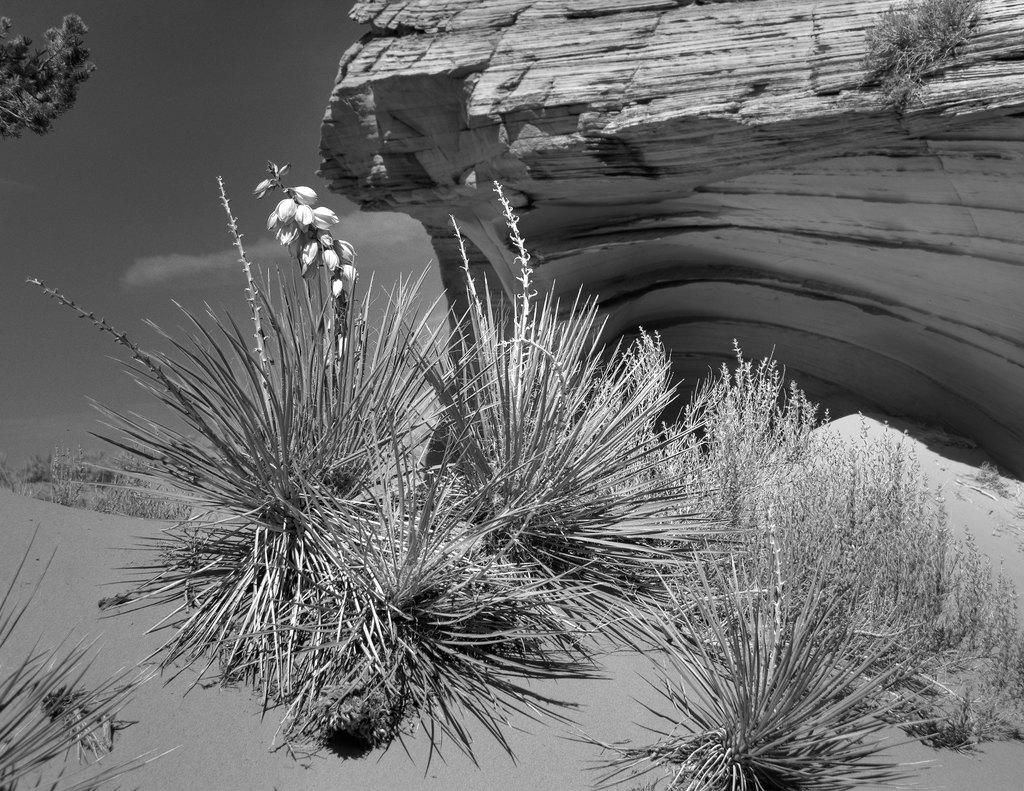What is the color scheme of the image? The image is black and white. What type of natural elements can be seen in the image? There are plants, sand, rocks, and trees in the image. What is visible in the background of the image? The sky is visible in the background of the image. What can be observed in the sky? There are clouds in the sky. What type of calculator is being used by the actor in the image? There is no actor or calculator present in the image. What type of town can be seen in the image? There is no town visible in the image; it features natural elements such as plants, sand, rocks, and trees. 